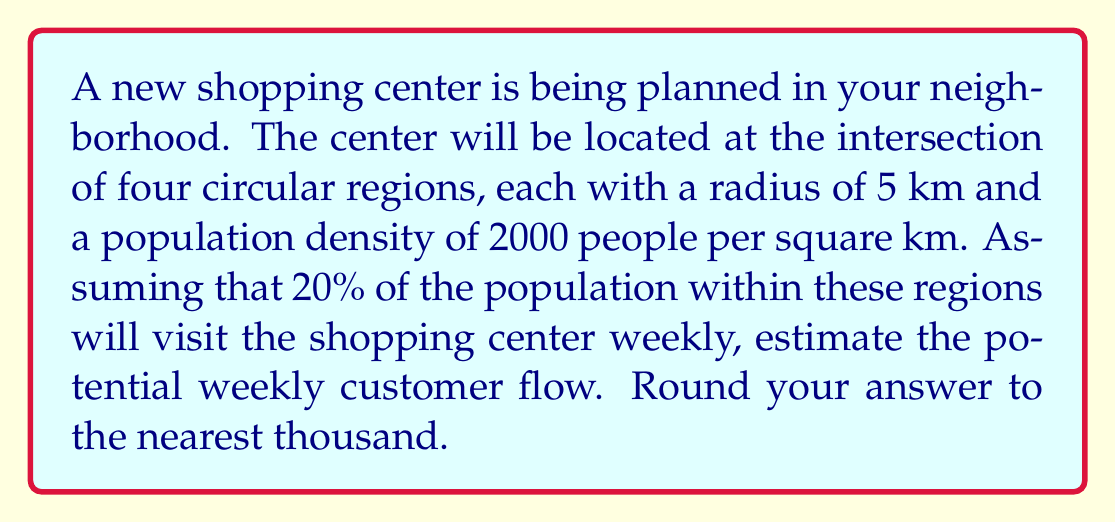Give your solution to this math problem. Let's approach this step-by-step:

1) First, we need to calculate the area of the region from which customers will come. This is the area of the intersection of four circles, each with a radius of 5 km.

2) The area of this intersection can be approximated by a square with side length equal to the diameter of one circle. The area of this square is:

   $$A = (2r)^2 = (2 * 5)^2 = 100\text{ km}^2$$

3) Now, we can calculate the total population in this area:

   $$\text{Population} = \text{Area} * \text{Density} = 100\text{ km}^2 * 2000\text{ people/km}^2 = 200,000\text{ people}$$

4) We're told that 20% of this population will visit the shopping center weekly. To calculate this:

   $$\text{Weekly visitors} = 20\% * 200,000 = 0.2 * 200,000 = 40,000\text{ people}$$

5) Rounding to the nearest thousand:

   $$40,000\text{ rounds to 40,000}$$

Therefore, the estimated potential weekly customer flow is 40,000 people.
Answer: 40,000 people 